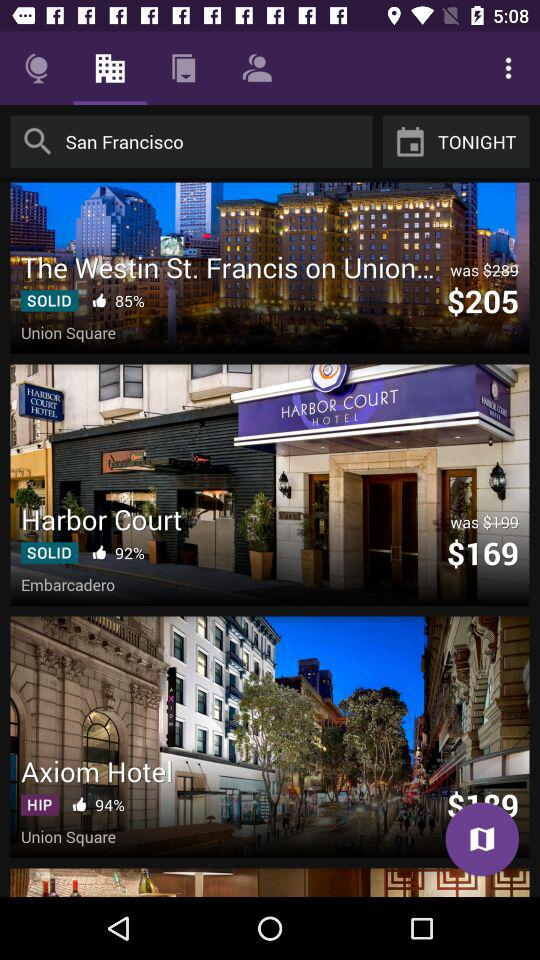How many hotels are displayed on the screen?
Answer the question using a single word or phrase. 3 